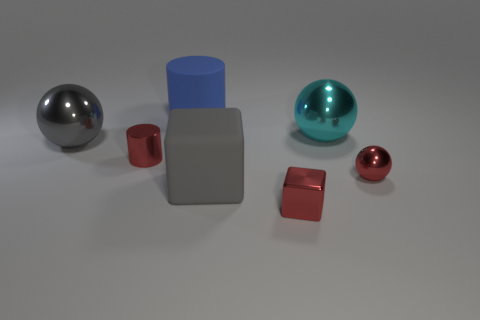Is the number of big objects left of the large cylinder the same as the number of matte spheres?
Provide a short and direct response. No. How many objects are either large shiny things left of the cyan metallic object or tiny green shiny objects?
Your answer should be very brief. 1. Does the shiny object left of the tiny red metallic cylinder have the same color as the matte cube?
Provide a succinct answer. Yes. What size is the matte object that is in front of the gray metal object?
Offer a very short reply. Large. What is the shape of the big shiny thing that is right of the small object in front of the tiny metallic sphere?
Ensure brevity in your answer.  Sphere. The other tiny object that is the same shape as the cyan thing is what color?
Keep it short and to the point. Red. There is a gray object in front of the gray shiny object; is it the same size as the tiny red metal cylinder?
Your response must be concise. No. The object that is the same color as the large rubber block is what shape?
Offer a terse response. Sphere. What number of big cylinders have the same material as the gray block?
Your answer should be very brief. 1. The cylinder that is behind the ball that is behind the large gray object that is behind the small red cylinder is made of what material?
Ensure brevity in your answer.  Rubber. 